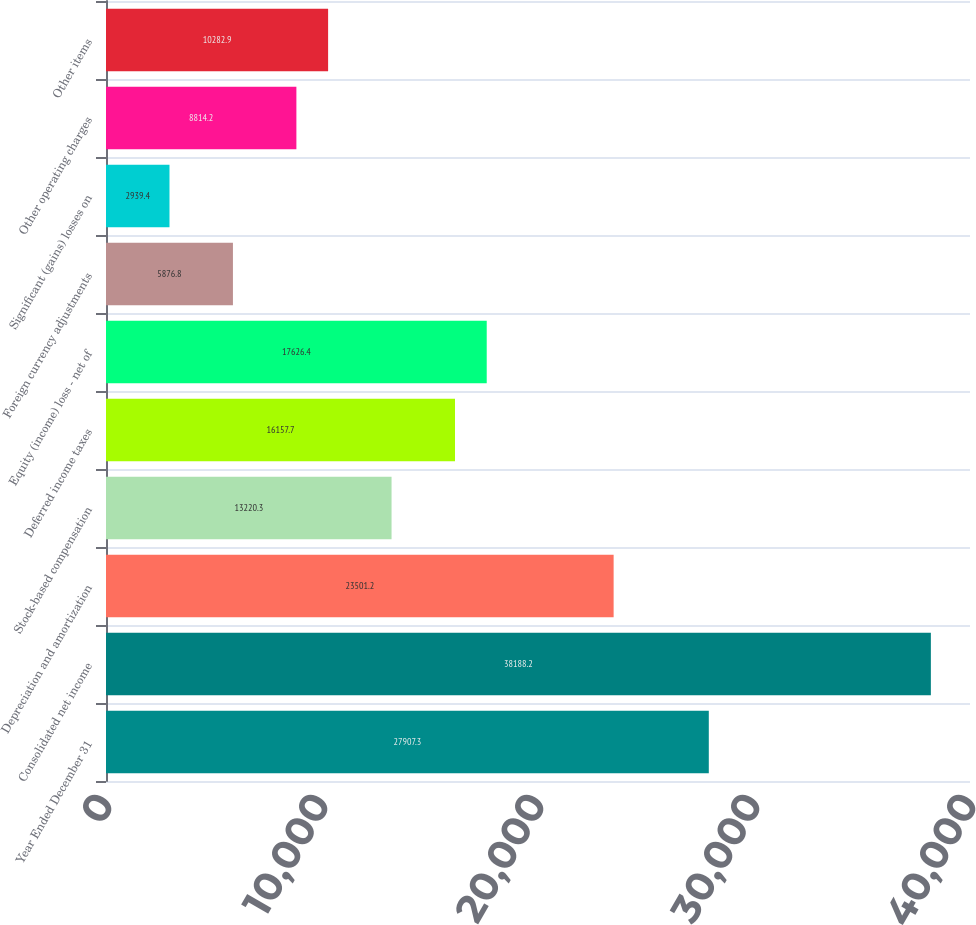<chart> <loc_0><loc_0><loc_500><loc_500><bar_chart><fcel>Year Ended December 31<fcel>Consolidated net income<fcel>Depreciation and amortization<fcel>Stock-based compensation<fcel>Deferred income taxes<fcel>Equity (income) loss - net of<fcel>Foreign currency adjustments<fcel>Significant (gains) losses on<fcel>Other operating charges<fcel>Other items<nl><fcel>27907.3<fcel>38188.2<fcel>23501.2<fcel>13220.3<fcel>16157.7<fcel>17626.4<fcel>5876.8<fcel>2939.4<fcel>8814.2<fcel>10282.9<nl></chart> 